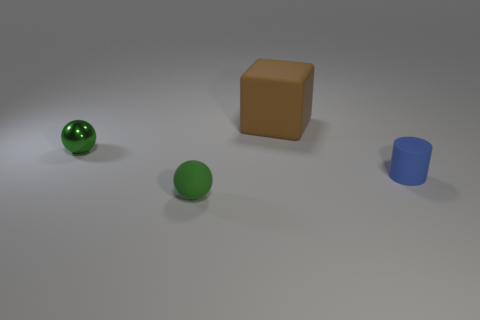Subtract all green balls. How many were subtracted if there are1green balls left? 1 Add 4 small green blocks. How many objects exist? 8 Subtract all cubes. How many objects are left? 3 Subtract all cubes. Subtract all blue metallic cylinders. How many objects are left? 3 Add 3 blue things. How many blue things are left? 4 Add 4 blue rubber objects. How many blue rubber objects exist? 5 Subtract 0 yellow cubes. How many objects are left? 4 